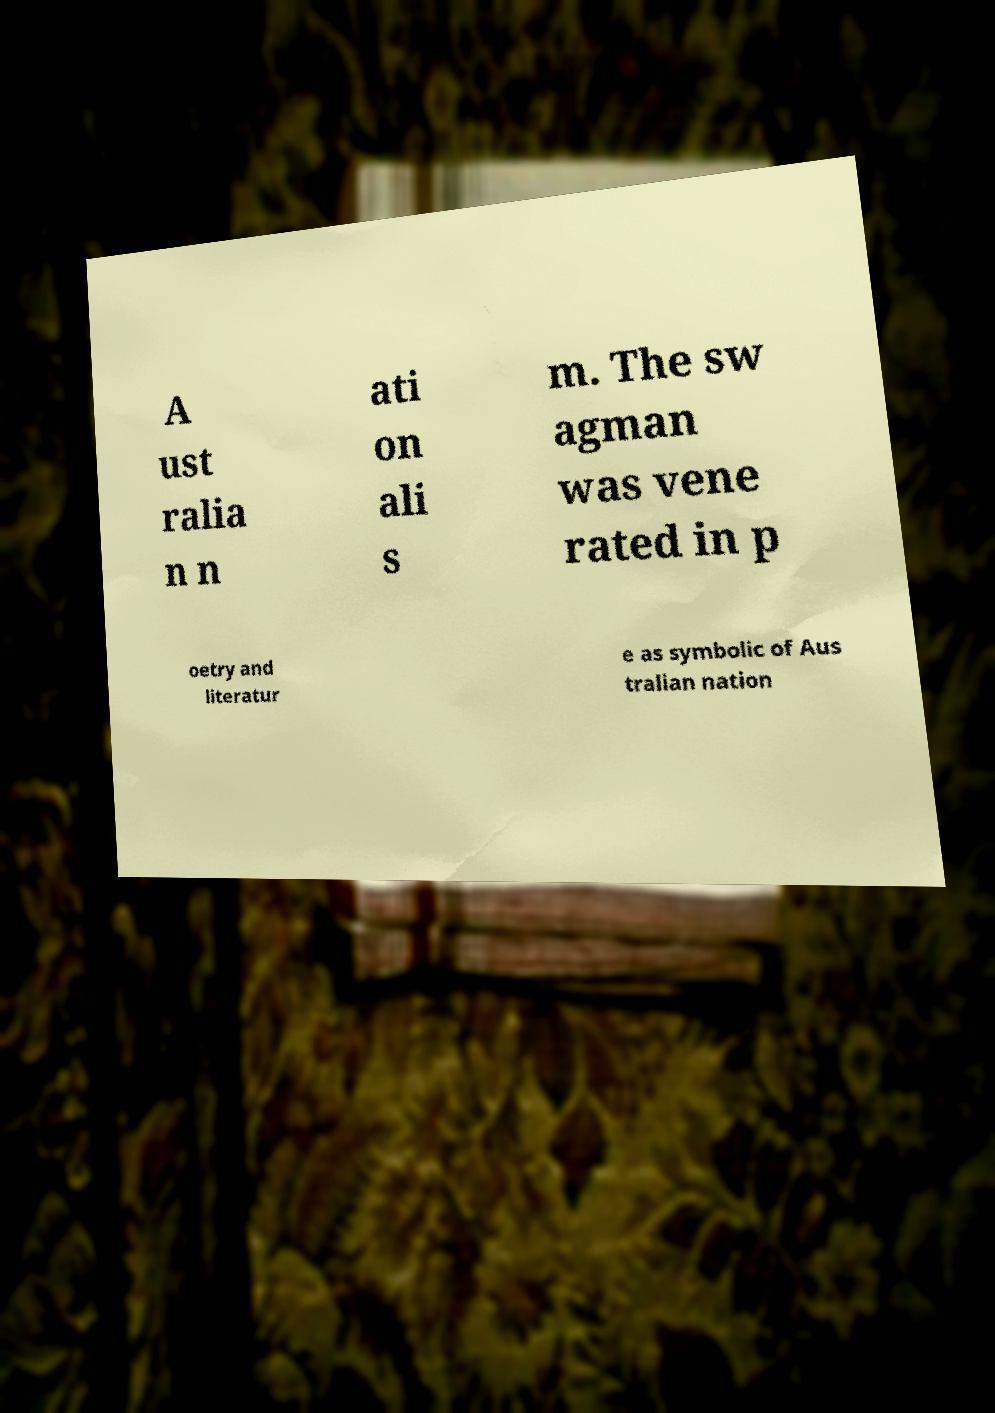Can you accurately transcribe the text from the provided image for me? A ust ralia n n ati on ali s m. The sw agman was vene rated in p oetry and literatur e as symbolic of Aus tralian nation 